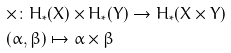Convert formula to latex. <formula><loc_0><loc_0><loc_500><loc_500>& \times \colon H _ { * } ( X ) \times H _ { * } ( Y ) \to H _ { * } ( X \times Y ) \\ & ( \alpha , \beta ) \mapsto \alpha \times \beta</formula> 